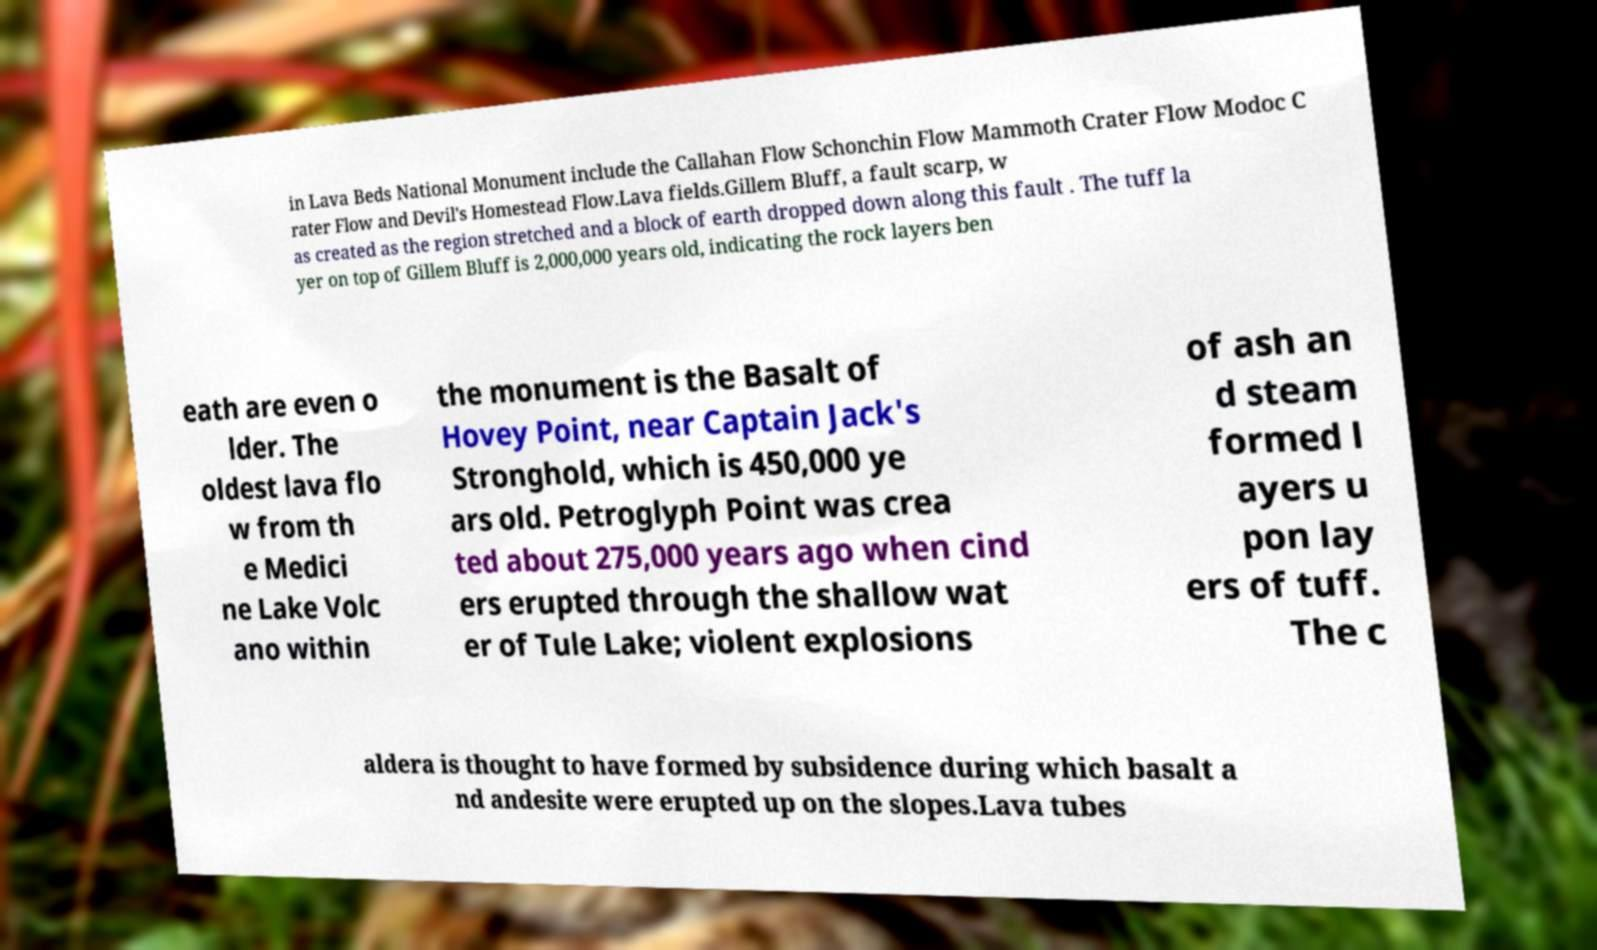Please identify and transcribe the text found in this image. in Lava Beds National Monument include the Callahan Flow Schonchin Flow Mammoth Crater Flow Modoc C rater Flow and Devil's Homestead Flow.Lava fields.Gillem Bluff, a fault scarp, w as created as the region stretched and a block of earth dropped down along this fault . The tuff la yer on top of Gillem Bluff is 2,000,000 years old, indicating the rock layers ben eath are even o lder. The oldest lava flo w from th e Medici ne Lake Volc ano within the monument is the Basalt of Hovey Point, near Captain Jack's Stronghold, which is 450,000 ye ars old. Petroglyph Point was crea ted about 275,000 years ago when cind ers erupted through the shallow wat er of Tule Lake; violent explosions of ash an d steam formed l ayers u pon lay ers of tuff. The c aldera is thought to have formed by subsidence during which basalt a nd andesite were erupted up on the slopes.Lava tubes 